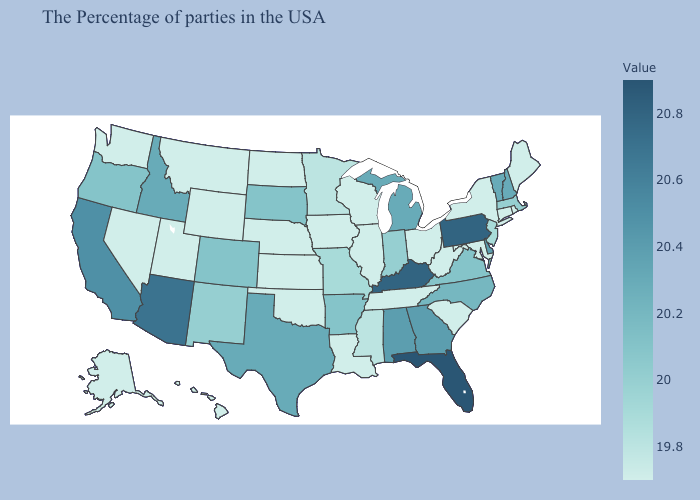Does North Carolina have the lowest value in the South?
Quick response, please. No. Which states have the highest value in the USA?
Write a very short answer. Florida. Which states have the lowest value in the MidWest?
Concise answer only. Ohio, Wisconsin, Illinois, Iowa, Kansas, Nebraska, North Dakota. Does the map have missing data?
Be succinct. No. Which states have the lowest value in the USA?
Quick response, please. Maine, Rhode Island, Connecticut, New York, Maryland, South Carolina, West Virginia, Ohio, Tennessee, Wisconsin, Illinois, Louisiana, Iowa, Kansas, Nebraska, Oklahoma, North Dakota, Wyoming, Utah, Montana, Nevada, Washington, Alaska, Hawaii. Among the states that border Oregon , which have the highest value?
Quick response, please. California. Which states have the highest value in the USA?
Give a very brief answer. Florida. Does Pennsylvania have the highest value in the Northeast?
Keep it brief. Yes. 